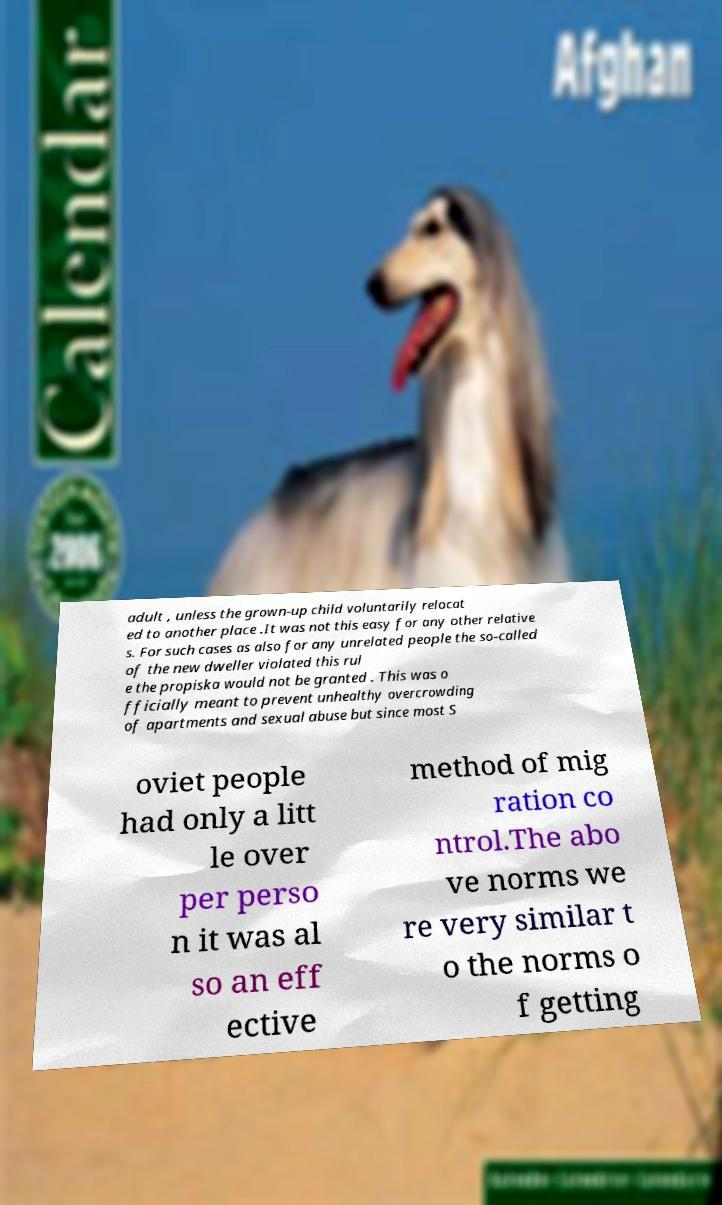Can you read and provide the text displayed in the image?This photo seems to have some interesting text. Can you extract and type it out for me? adult , unless the grown-up child voluntarily relocat ed to another place .It was not this easy for any other relative s. For such cases as also for any unrelated people the so-called of the new dweller violated this rul e the propiska would not be granted . This was o fficially meant to prevent unhealthy overcrowding of apartments and sexual abuse but since most S oviet people had only a litt le over per perso n it was al so an eff ective method of mig ration co ntrol.The abo ve norms we re very similar t o the norms o f getting 